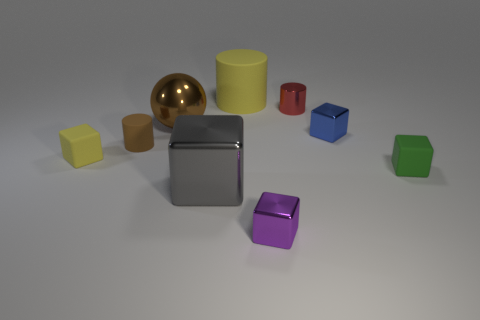What number of brown objects are either big rubber things or large objects?
Give a very brief answer. 1. What is the material of the green object that is the same size as the purple object?
Your response must be concise. Rubber. There is a object that is both behind the brown shiny thing and to the right of the big rubber thing; what is its shape?
Your response must be concise. Cylinder. What is the color of the matte cylinder that is the same size as the red object?
Provide a succinct answer. Brown. Does the metallic block on the left side of the large yellow object have the same size as the shiny ball that is left of the purple metal block?
Provide a short and direct response. Yes. What is the size of the matte block left of the rubber cube that is on the right side of the purple metallic cube to the left of the green cube?
Offer a very short reply. Small. The tiny shiny thing on the right side of the tiny cylinder on the right side of the big gray object is what shape?
Provide a succinct answer. Cube. There is a large object behind the big brown metal thing; is its color the same as the tiny metallic cylinder?
Provide a succinct answer. No. There is a matte thing that is on the right side of the big shiny cube and to the left of the small blue object; what is its color?
Offer a terse response. Yellow. Are there any big gray balls made of the same material as the big gray cube?
Offer a terse response. No. 